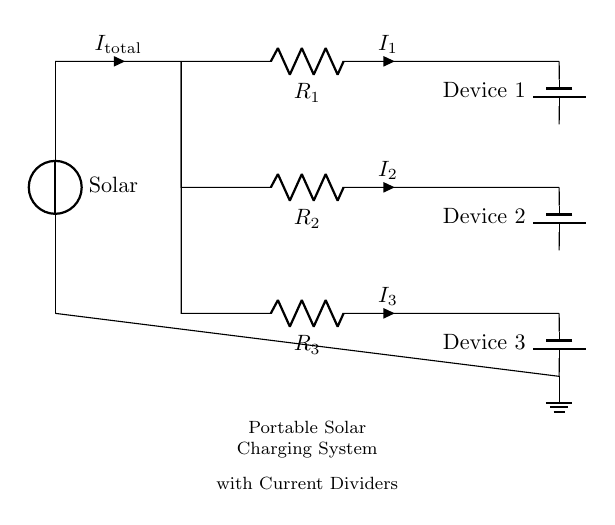What type of device is connected to the solar panel? The circuit diagram shows that the solar panel supplies power to multiple devices, specifically batteries indicating portable devices. This is evident from the labeling of the components where the “Device 1”, “Device 2”, and “Device 3” are connected to the circuit after the resistors.
Answer: battery What is the total current entering the circuit? The total current entering the circuit is represented as I total on the diagram. It is the current that flows from the solar panel before it gets divided among the resistors connected to the devices. As per the conventions in the circuit, it can be recognized that it is the input current into the parallel resistive loads.
Answer: I total How many resistors are present in the circuit? By examining the circuit diagram, we can count the resistors labeled R1, R2, and R3. The presence of three resistors implies that the current dividing action occurs over these components to supply the power to the connected devices.
Answer: 3 What does R1, R2, and R3 represent in this circuit? R1, R2, and R3 are resistors, each representing different load impedances for the devices connected in parallel to the solar panel. The resistors not only regulate the current flowing into each device but also affect the voltage drop across each device dictated by Ohm's Law.
Answer: resistors Which device will receive the least current? Given that R2 is positioned between two resistors in parallel, its resistance is critical in determining current division. If R2 is larger than R1 and R3, then Device 2 will receive the least current, as it has the highest resistance in this configuration resulting in less current flow according to the current divider principle.
Answer: Device 2 How does current division work in this circuit? Current division occurs as the total current from the solar panel flows through parallel resistors (R1, R2, and R3). The current is distributed inversely proportional to each resistor's value; thus, lower resistance receives more current while higher resistance gets less. This principle is essential for ensuring that all devices receive appropriate power levels without overloading the circuit.
Answer: proportional to resistance 